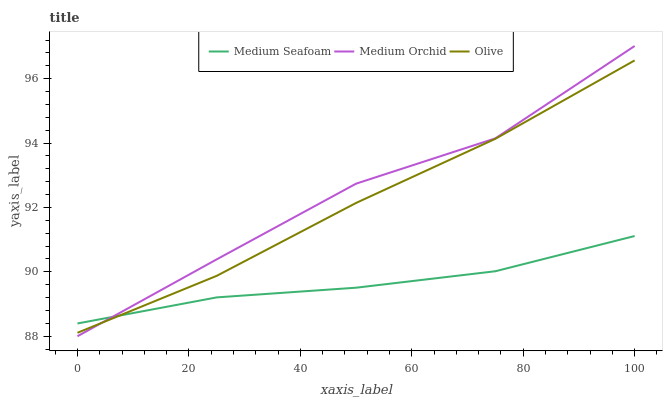Does Medium Seafoam have the minimum area under the curve?
Answer yes or no. Yes. Does Medium Orchid have the maximum area under the curve?
Answer yes or no. Yes. Does Medium Orchid have the minimum area under the curve?
Answer yes or no. No. Does Medium Seafoam have the maximum area under the curve?
Answer yes or no. No. Is Olive the smoothest?
Answer yes or no. Yes. Is Medium Orchid the roughest?
Answer yes or no. Yes. Is Medium Seafoam the smoothest?
Answer yes or no. No. Is Medium Seafoam the roughest?
Answer yes or no. No. Does Medium Orchid have the lowest value?
Answer yes or no. Yes. Does Medium Seafoam have the lowest value?
Answer yes or no. No. Does Medium Orchid have the highest value?
Answer yes or no. Yes. Does Medium Seafoam have the highest value?
Answer yes or no. No. Does Medium Orchid intersect Olive?
Answer yes or no. Yes. Is Medium Orchid less than Olive?
Answer yes or no. No. Is Medium Orchid greater than Olive?
Answer yes or no. No. 